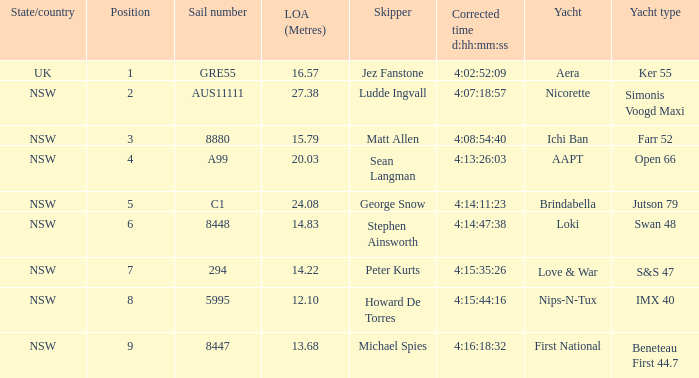Which racing boat had a corrected time of 4:14:11:23? Brindabella. 